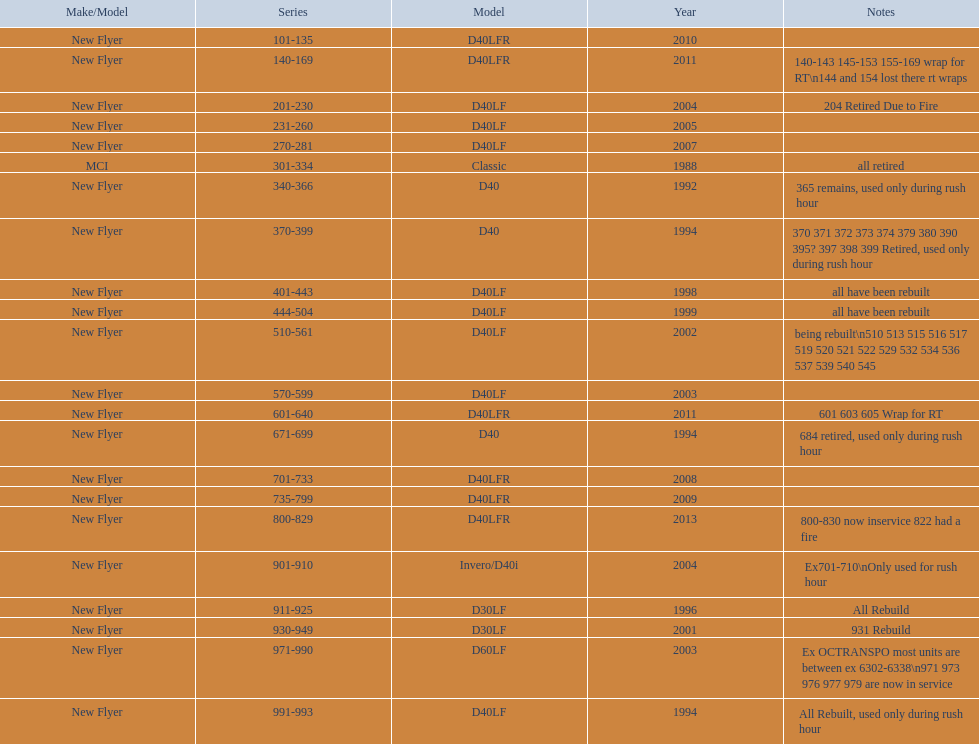What are all the varieties of buses? D40LFR, D40LF, Classic, D40, Invero/D40i, D30LF, D60LF. Of these buses, which series is the earliest? 301-334. Which is the latest? 800-829. 